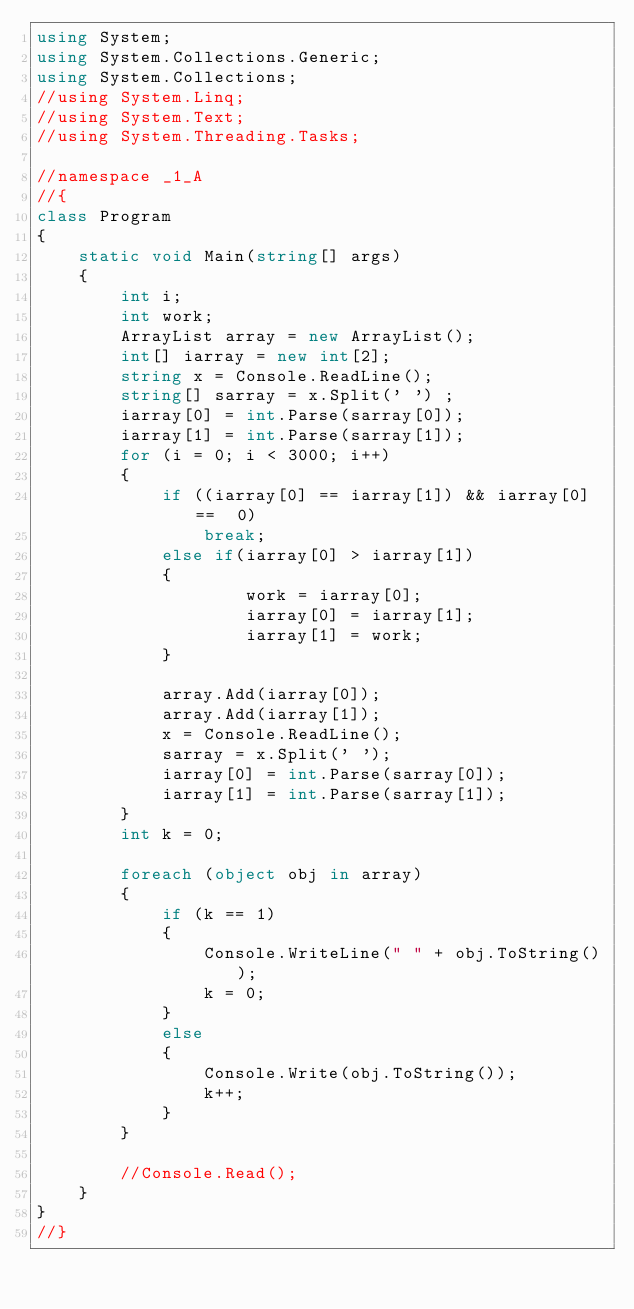<code> <loc_0><loc_0><loc_500><loc_500><_C#_>using System;
using System.Collections.Generic;
using System.Collections;
//using System.Linq;
//using System.Text;
//using System.Threading.Tasks;

//namespace _1_A
//{
class Program
{
    static void Main(string[] args)
    {
        int i;
        int work;
        ArrayList array = new ArrayList();
        int[] iarray = new int[2];
        string x = Console.ReadLine();
        string[] sarray = x.Split(' ') ;
        iarray[0] = int.Parse(sarray[0]);
        iarray[1] = int.Parse(sarray[1]);
        for (i = 0; i < 3000; i++)
        {
            if ((iarray[0] == iarray[1]) && iarray[0] ==  0)
                break;
            else if(iarray[0] > iarray[1])
            {
                    work = iarray[0];
                    iarray[0] = iarray[1];
                    iarray[1] = work;
            }

            array.Add(iarray[0]);
            array.Add(iarray[1]);
            x = Console.ReadLine();
            sarray = x.Split(' ');
            iarray[0] = int.Parse(sarray[0]);
            iarray[1] = int.Parse(sarray[1]);
        }
        int k = 0;

        foreach (object obj in array)
        {
            if (k == 1)
            {
                Console.WriteLine(" " + obj.ToString());
                k = 0;
            }
            else
            {
                Console.Write(obj.ToString());
                k++;
            }
        }

        //Console.Read();
    }
}
//}</code> 